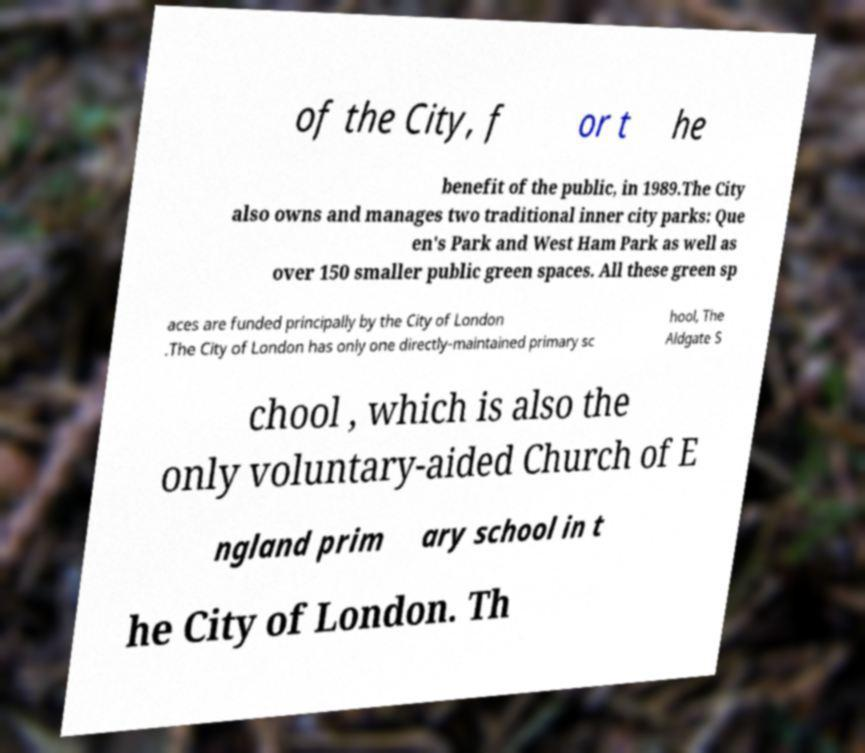Can you read and provide the text displayed in the image?This photo seems to have some interesting text. Can you extract and type it out for me? of the City, f or t he benefit of the public, in 1989.The City also owns and manages two traditional inner city parks: Que en's Park and West Ham Park as well as over 150 smaller public green spaces. All these green sp aces are funded principally by the City of London .The City of London has only one directly-maintained primary sc hool, The Aldgate S chool , which is also the only voluntary-aided Church of E ngland prim ary school in t he City of London. Th 